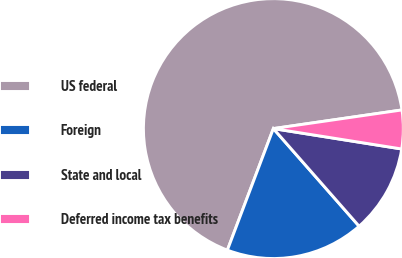<chart> <loc_0><loc_0><loc_500><loc_500><pie_chart><fcel>US federal<fcel>Foreign<fcel>State and local<fcel>Deferred income tax benefits<nl><fcel>66.95%<fcel>17.23%<fcel>11.02%<fcel>4.8%<nl></chart> 